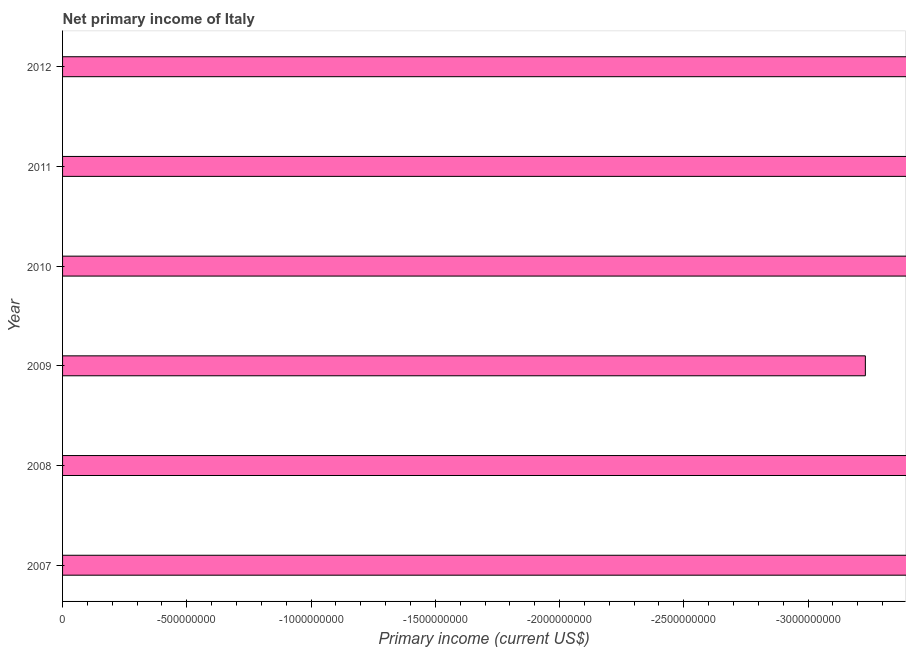What is the title of the graph?
Your answer should be compact. Net primary income of Italy. What is the label or title of the X-axis?
Offer a terse response. Primary income (current US$). What is the label or title of the Y-axis?
Offer a terse response. Year. Across all years, what is the minimum amount of primary income?
Your response must be concise. 0. In how many years, is the amount of primary income greater than the average amount of primary income taken over all years?
Give a very brief answer. 0. What is the difference between two consecutive major ticks on the X-axis?
Provide a short and direct response. 5.00e+08. Are the values on the major ticks of X-axis written in scientific E-notation?
Provide a short and direct response. No. What is the Primary income (current US$) of 2008?
Keep it short and to the point. 0. What is the Primary income (current US$) in 2009?
Provide a succinct answer. 0. What is the Primary income (current US$) in 2010?
Keep it short and to the point. 0. What is the Primary income (current US$) of 2011?
Your answer should be very brief. 0. 